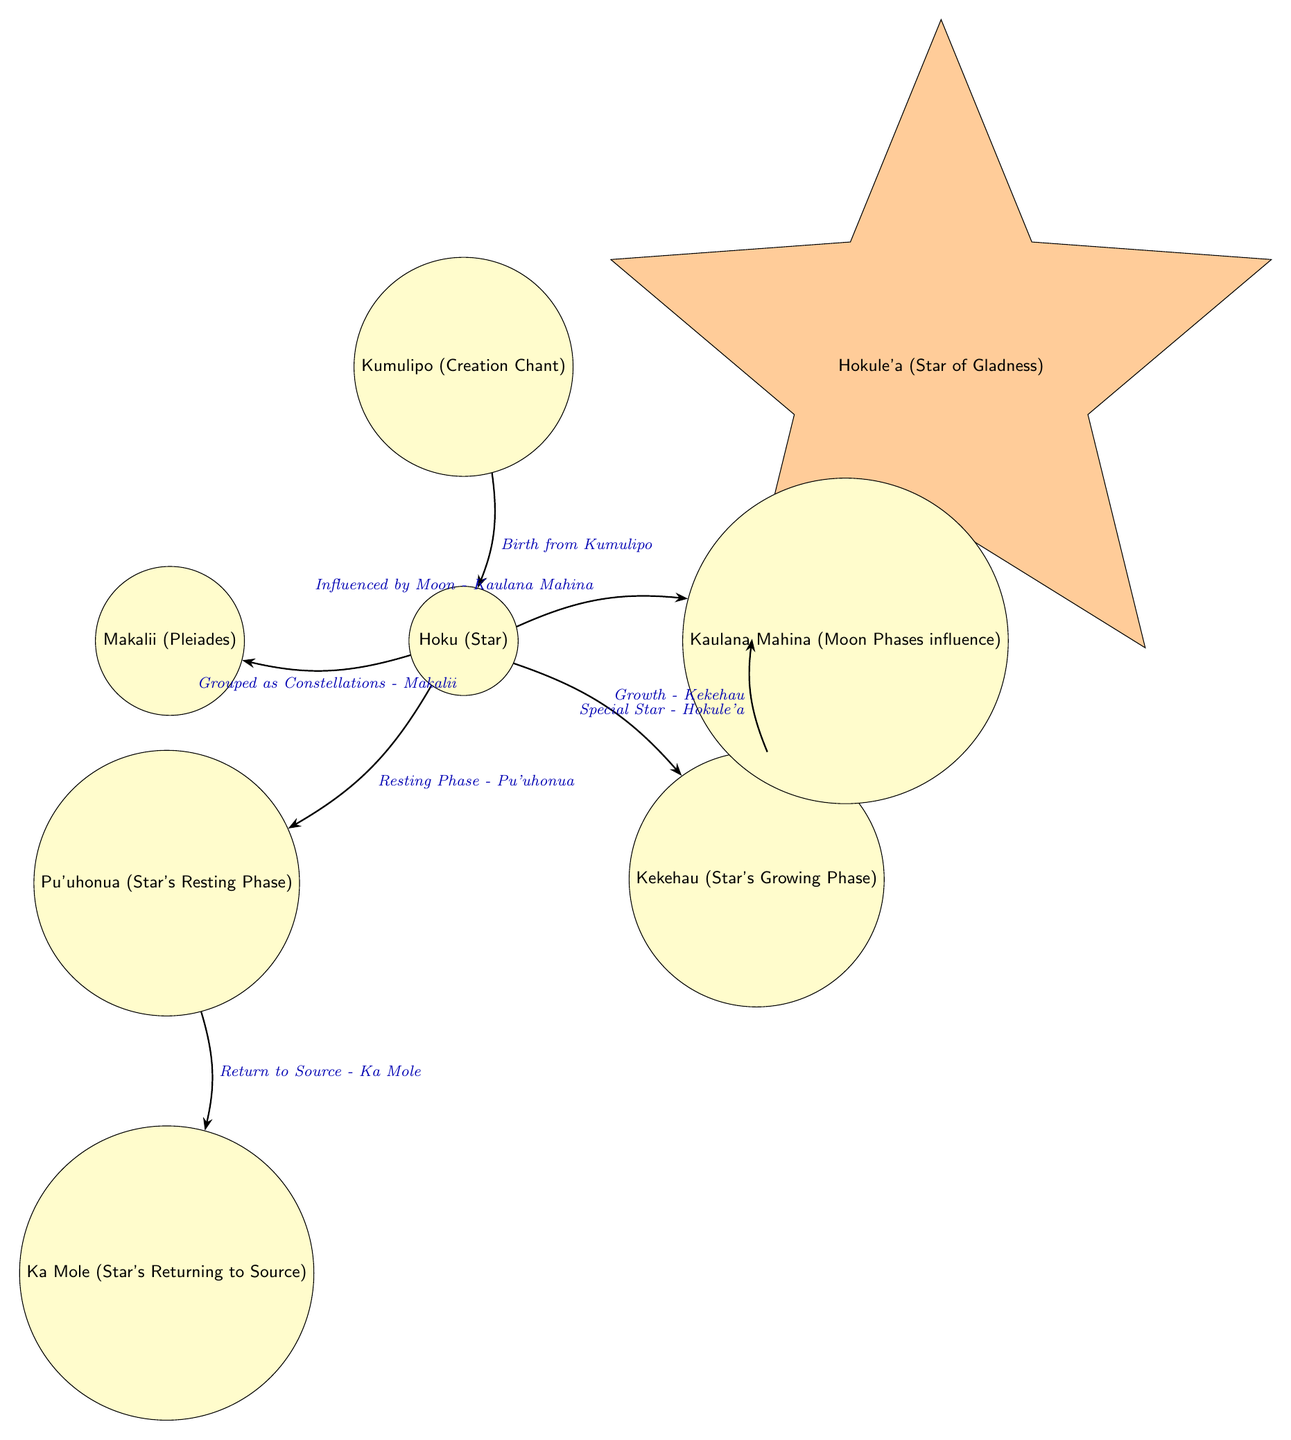What is the first node in the diagram? The first node is Kumulipo, which represents the creation chant. It is the starting point of the lifecycle of a star.
Answer: Kumulipo How many nodes are in the diagram? To find the number of nodes, we can list them: Kumulipo, Hoku, Kekehau, Hokule'a, Kaulana Mahina, Pu'uhonua, Makalii, and Ka Mole. This gives us a total of 8 nodes.
Answer: 8 Which node represents the special star? The special star is represented by Hokule'a, which is explicitly labeled in the diagram.
Answer: Hokule'a What phase directly follows the star's growth phase? After the star's growth phase (Kekehau), the next node is the special star (Hokule'a), indicating that it is the next stage in the lifecycle.
Answer: Hokule'a What is the relationship between Hoku and Pu'uhonua? The relationship is that Hoku (Star) has an edge leading to Pu'uhonua (Star's Resting Phase), indicating that Hoku goes into resting phase next.
Answer: Resting Phase What is the significance of Kaulana Mahina in the lifecycle? Kaulana Mahina influences Hoku (Star), showing that the moon phases affect the lifecycle of the star, which is depicted in the edge labeling.
Answer: Influenced by Moon Which node indicates the return to source? The node indicating the return to source is Ka Mole, which signifies the final phase of a star's lifecycle.
Answer: Ka Mole Which nodes are grouped as constellations? The grouping as constellations refers to Makalii, which is the node highlighted for grouping stars together, specifically noted as a constellation.
Answer: Makalii What does the edge from Kumulipo to Hoku represent? The edge from Kumulipo to Hoku is labeled "Birth from Kumulipo," indicating the origin of the star from the creation narrative.
Answer: Birth from Kumulipo 